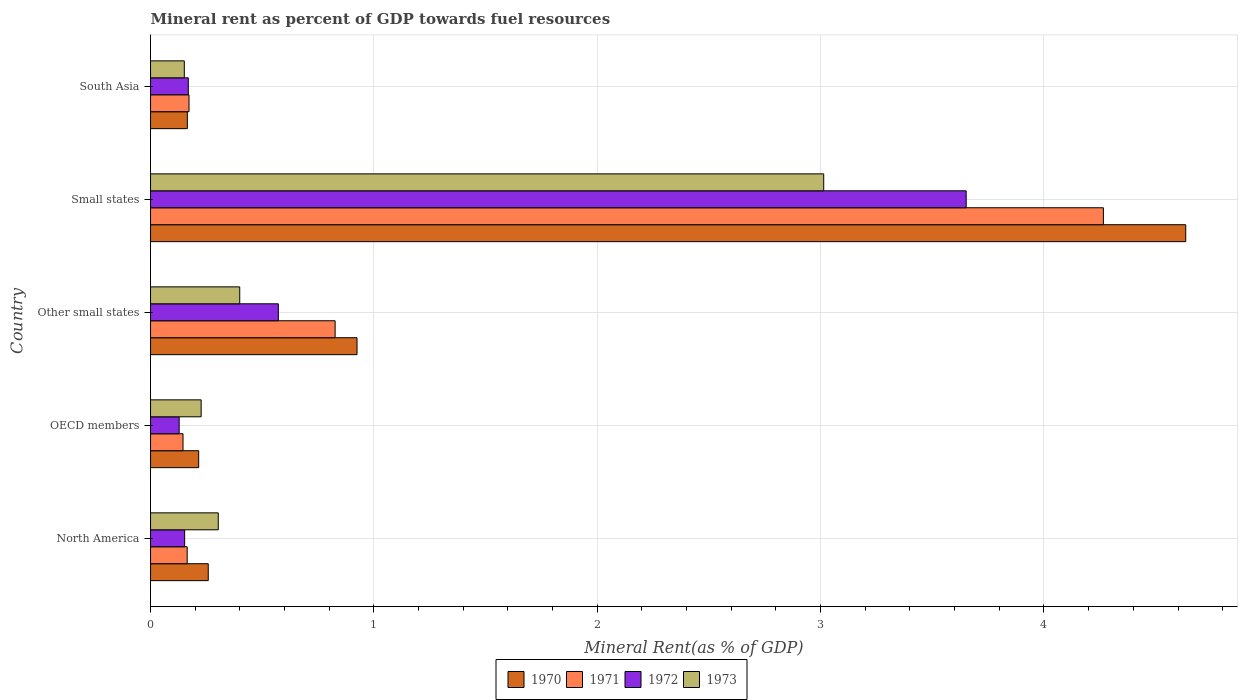How many different coloured bars are there?
Ensure brevity in your answer.  4. How many bars are there on the 1st tick from the top?
Make the answer very short. 4. How many bars are there on the 3rd tick from the bottom?
Offer a very short reply. 4. What is the mineral rent in 1971 in South Asia?
Your response must be concise. 0.17. Across all countries, what is the maximum mineral rent in 1973?
Your response must be concise. 3.01. Across all countries, what is the minimum mineral rent in 1971?
Make the answer very short. 0.15. In which country was the mineral rent in 1973 maximum?
Your answer should be compact. Small states. What is the total mineral rent in 1971 in the graph?
Give a very brief answer. 5.57. What is the difference between the mineral rent in 1971 in Small states and that in South Asia?
Your response must be concise. 4.09. What is the difference between the mineral rent in 1972 in OECD members and the mineral rent in 1970 in Small states?
Make the answer very short. -4.51. What is the average mineral rent in 1970 per country?
Make the answer very short. 1.24. What is the difference between the mineral rent in 1973 and mineral rent in 1970 in Other small states?
Offer a terse response. -0.53. In how many countries, is the mineral rent in 1973 greater than 4.6 %?
Your answer should be very brief. 0. What is the ratio of the mineral rent in 1972 in OECD members to that in Small states?
Your response must be concise. 0.04. Is the difference between the mineral rent in 1973 in Other small states and South Asia greater than the difference between the mineral rent in 1970 in Other small states and South Asia?
Keep it short and to the point. No. What is the difference between the highest and the second highest mineral rent in 1972?
Keep it short and to the point. 3.08. What is the difference between the highest and the lowest mineral rent in 1972?
Your answer should be compact. 3.52. In how many countries, is the mineral rent in 1973 greater than the average mineral rent in 1973 taken over all countries?
Offer a terse response. 1. What does the 1st bar from the top in Other small states represents?
Offer a very short reply. 1973. What does the 4th bar from the bottom in Small states represents?
Keep it short and to the point. 1973. Is it the case that in every country, the sum of the mineral rent in 1970 and mineral rent in 1973 is greater than the mineral rent in 1971?
Your answer should be very brief. Yes. How many bars are there?
Make the answer very short. 20. What is the difference between two consecutive major ticks on the X-axis?
Your response must be concise. 1. Are the values on the major ticks of X-axis written in scientific E-notation?
Make the answer very short. No. Does the graph contain any zero values?
Provide a short and direct response. No. What is the title of the graph?
Keep it short and to the point. Mineral rent as percent of GDP towards fuel resources. What is the label or title of the X-axis?
Your answer should be very brief. Mineral Rent(as % of GDP). What is the Mineral Rent(as % of GDP) of 1970 in North America?
Your response must be concise. 0.26. What is the Mineral Rent(as % of GDP) of 1971 in North America?
Provide a succinct answer. 0.16. What is the Mineral Rent(as % of GDP) in 1972 in North America?
Your answer should be compact. 0.15. What is the Mineral Rent(as % of GDP) of 1973 in North America?
Provide a short and direct response. 0.3. What is the Mineral Rent(as % of GDP) of 1970 in OECD members?
Provide a succinct answer. 0.22. What is the Mineral Rent(as % of GDP) of 1971 in OECD members?
Provide a succinct answer. 0.15. What is the Mineral Rent(as % of GDP) in 1972 in OECD members?
Your answer should be compact. 0.13. What is the Mineral Rent(as % of GDP) of 1973 in OECD members?
Offer a very short reply. 0.23. What is the Mineral Rent(as % of GDP) in 1970 in Other small states?
Your answer should be compact. 0.92. What is the Mineral Rent(as % of GDP) of 1971 in Other small states?
Keep it short and to the point. 0.83. What is the Mineral Rent(as % of GDP) in 1972 in Other small states?
Ensure brevity in your answer.  0.57. What is the Mineral Rent(as % of GDP) in 1973 in Other small states?
Your response must be concise. 0.4. What is the Mineral Rent(as % of GDP) of 1970 in Small states?
Keep it short and to the point. 4.63. What is the Mineral Rent(as % of GDP) of 1971 in Small states?
Your answer should be very brief. 4.27. What is the Mineral Rent(as % of GDP) of 1972 in Small states?
Provide a succinct answer. 3.65. What is the Mineral Rent(as % of GDP) in 1973 in Small states?
Your response must be concise. 3.01. What is the Mineral Rent(as % of GDP) of 1970 in South Asia?
Ensure brevity in your answer.  0.16. What is the Mineral Rent(as % of GDP) in 1971 in South Asia?
Provide a succinct answer. 0.17. What is the Mineral Rent(as % of GDP) in 1972 in South Asia?
Offer a very short reply. 0.17. What is the Mineral Rent(as % of GDP) of 1973 in South Asia?
Provide a succinct answer. 0.15. Across all countries, what is the maximum Mineral Rent(as % of GDP) of 1970?
Keep it short and to the point. 4.63. Across all countries, what is the maximum Mineral Rent(as % of GDP) in 1971?
Provide a succinct answer. 4.27. Across all countries, what is the maximum Mineral Rent(as % of GDP) of 1972?
Your answer should be compact. 3.65. Across all countries, what is the maximum Mineral Rent(as % of GDP) of 1973?
Your response must be concise. 3.01. Across all countries, what is the minimum Mineral Rent(as % of GDP) of 1970?
Offer a very short reply. 0.16. Across all countries, what is the minimum Mineral Rent(as % of GDP) in 1971?
Provide a short and direct response. 0.15. Across all countries, what is the minimum Mineral Rent(as % of GDP) in 1972?
Your response must be concise. 0.13. Across all countries, what is the minimum Mineral Rent(as % of GDP) in 1973?
Give a very brief answer. 0.15. What is the total Mineral Rent(as % of GDP) of 1970 in the graph?
Provide a short and direct response. 6.2. What is the total Mineral Rent(as % of GDP) in 1971 in the graph?
Your answer should be compact. 5.57. What is the total Mineral Rent(as % of GDP) in 1972 in the graph?
Provide a short and direct response. 4.67. What is the total Mineral Rent(as % of GDP) in 1973 in the graph?
Provide a short and direct response. 4.09. What is the difference between the Mineral Rent(as % of GDP) of 1970 in North America and that in OECD members?
Ensure brevity in your answer.  0.04. What is the difference between the Mineral Rent(as % of GDP) in 1971 in North America and that in OECD members?
Keep it short and to the point. 0.02. What is the difference between the Mineral Rent(as % of GDP) in 1972 in North America and that in OECD members?
Your answer should be compact. 0.02. What is the difference between the Mineral Rent(as % of GDP) of 1973 in North America and that in OECD members?
Provide a short and direct response. 0.08. What is the difference between the Mineral Rent(as % of GDP) in 1970 in North America and that in Other small states?
Offer a terse response. -0.67. What is the difference between the Mineral Rent(as % of GDP) of 1971 in North America and that in Other small states?
Offer a very short reply. -0.66. What is the difference between the Mineral Rent(as % of GDP) in 1972 in North America and that in Other small states?
Keep it short and to the point. -0.42. What is the difference between the Mineral Rent(as % of GDP) of 1973 in North America and that in Other small states?
Provide a succinct answer. -0.1. What is the difference between the Mineral Rent(as % of GDP) of 1970 in North America and that in Small states?
Offer a terse response. -4.38. What is the difference between the Mineral Rent(as % of GDP) in 1971 in North America and that in Small states?
Your response must be concise. -4.1. What is the difference between the Mineral Rent(as % of GDP) of 1972 in North America and that in Small states?
Your response must be concise. -3.5. What is the difference between the Mineral Rent(as % of GDP) of 1973 in North America and that in Small states?
Your answer should be very brief. -2.71. What is the difference between the Mineral Rent(as % of GDP) in 1970 in North America and that in South Asia?
Your response must be concise. 0.09. What is the difference between the Mineral Rent(as % of GDP) in 1971 in North America and that in South Asia?
Keep it short and to the point. -0.01. What is the difference between the Mineral Rent(as % of GDP) of 1972 in North America and that in South Asia?
Offer a very short reply. -0.02. What is the difference between the Mineral Rent(as % of GDP) of 1973 in North America and that in South Asia?
Keep it short and to the point. 0.15. What is the difference between the Mineral Rent(as % of GDP) of 1970 in OECD members and that in Other small states?
Your answer should be compact. -0.71. What is the difference between the Mineral Rent(as % of GDP) of 1971 in OECD members and that in Other small states?
Provide a short and direct response. -0.68. What is the difference between the Mineral Rent(as % of GDP) of 1972 in OECD members and that in Other small states?
Provide a succinct answer. -0.44. What is the difference between the Mineral Rent(as % of GDP) in 1973 in OECD members and that in Other small states?
Keep it short and to the point. -0.17. What is the difference between the Mineral Rent(as % of GDP) of 1970 in OECD members and that in Small states?
Offer a terse response. -4.42. What is the difference between the Mineral Rent(as % of GDP) in 1971 in OECD members and that in Small states?
Make the answer very short. -4.12. What is the difference between the Mineral Rent(as % of GDP) of 1972 in OECD members and that in Small states?
Give a very brief answer. -3.52. What is the difference between the Mineral Rent(as % of GDP) of 1973 in OECD members and that in Small states?
Ensure brevity in your answer.  -2.79. What is the difference between the Mineral Rent(as % of GDP) in 1970 in OECD members and that in South Asia?
Offer a terse response. 0.05. What is the difference between the Mineral Rent(as % of GDP) of 1971 in OECD members and that in South Asia?
Ensure brevity in your answer.  -0.03. What is the difference between the Mineral Rent(as % of GDP) of 1972 in OECD members and that in South Asia?
Your answer should be very brief. -0.04. What is the difference between the Mineral Rent(as % of GDP) of 1973 in OECD members and that in South Asia?
Offer a very short reply. 0.08. What is the difference between the Mineral Rent(as % of GDP) of 1970 in Other small states and that in Small states?
Your response must be concise. -3.71. What is the difference between the Mineral Rent(as % of GDP) of 1971 in Other small states and that in Small states?
Keep it short and to the point. -3.44. What is the difference between the Mineral Rent(as % of GDP) in 1972 in Other small states and that in Small states?
Offer a very short reply. -3.08. What is the difference between the Mineral Rent(as % of GDP) of 1973 in Other small states and that in Small states?
Your answer should be compact. -2.61. What is the difference between the Mineral Rent(as % of GDP) of 1970 in Other small states and that in South Asia?
Your answer should be very brief. 0.76. What is the difference between the Mineral Rent(as % of GDP) in 1971 in Other small states and that in South Asia?
Make the answer very short. 0.65. What is the difference between the Mineral Rent(as % of GDP) of 1972 in Other small states and that in South Asia?
Give a very brief answer. 0.4. What is the difference between the Mineral Rent(as % of GDP) of 1973 in Other small states and that in South Asia?
Ensure brevity in your answer.  0.25. What is the difference between the Mineral Rent(as % of GDP) in 1970 in Small states and that in South Asia?
Offer a very short reply. 4.47. What is the difference between the Mineral Rent(as % of GDP) of 1971 in Small states and that in South Asia?
Your answer should be compact. 4.09. What is the difference between the Mineral Rent(as % of GDP) in 1972 in Small states and that in South Asia?
Offer a terse response. 3.48. What is the difference between the Mineral Rent(as % of GDP) in 1973 in Small states and that in South Asia?
Ensure brevity in your answer.  2.86. What is the difference between the Mineral Rent(as % of GDP) in 1970 in North America and the Mineral Rent(as % of GDP) in 1971 in OECD members?
Provide a short and direct response. 0.11. What is the difference between the Mineral Rent(as % of GDP) in 1970 in North America and the Mineral Rent(as % of GDP) in 1972 in OECD members?
Offer a very short reply. 0.13. What is the difference between the Mineral Rent(as % of GDP) of 1970 in North America and the Mineral Rent(as % of GDP) of 1973 in OECD members?
Provide a short and direct response. 0.03. What is the difference between the Mineral Rent(as % of GDP) of 1971 in North America and the Mineral Rent(as % of GDP) of 1972 in OECD members?
Offer a terse response. 0.04. What is the difference between the Mineral Rent(as % of GDP) of 1971 in North America and the Mineral Rent(as % of GDP) of 1973 in OECD members?
Offer a very short reply. -0.06. What is the difference between the Mineral Rent(as % of GDP) in 1972 in North America and the Mineral Rent(as % of GDP) in 1973 in OECD members?
Give a very brief answer. -0.07. What is the difference between the Mineral Rent(as % of GDP) in 1970 in North America and the Mineral Rent(as % of GDP) in 1971 in Other small states?
Ensure brevity in your answer.  -0.57. What is the difference between the Mineral Rent(as % of GDP) of 1970 in North America and the Mineral Rent(as % of GDP) of 1972 in Other small states?
Your response must be concise. -0.31. What is the difference between the Mineral Rent(as % of GDP) in 1970 in North America and the Mineral Rent(as % of GDP) in 1973 in Other small states?
Offer a terse response. -0.14. What is the difference between the Mineral Rent(as % of GDP) of 1971 in North America and the Mineral Rent(as % of GDP) of 1972 in Other small states?
Offer a terse response. -0.41. What is the difference between the Mineral Rent(as % of GDP) in 1971 in North America and the Mineral Rent(as % of GDP) in 1973 in Other small states?
Ensure brevity in your answer.  -0.24. What is the difference between the Mineral Rent(as % of GDP) of 1972 in North America and the Mineral Rent(as % of GDP) of 1973 in Other small states?
Your response must be concise. -0.25. What is the difference between the Mineral Rent(as % of GDP) in 1970 in North America and the Mineral Rent(as % of GDP) in 1971 in Small states?
Offer a terse response. -4.01. What is the difference between the Mineral Rent(as % of GDP) of 1970 in North America and the Mineral Rent(as % of GDP) of 1972 in Small states?
Offer a very short reply. -3.39. What is the difference between the Mineral Rent(as % of GDP) of 1970 in North America and the Mineral Rent(as % of GDP) of 1973 in Small states?
Provide a succinct answer. -2.76. What is the difference between the Mineral Rent(as % of GDP) of 1971 in North America and the Mineral Rent(as % of GDP) of 1972 in Small states?
Offer a very short reply. -3.49. What is the difference between the Mineral Rent(as % of GDP) in 1971 in North America and the Mineral Rent(as % of GDP) in 1973 in Small states?
Ensure brevity in your answer.  -2.85. What is the difference between the Mineral Rent(as % of GDP) in 1972 in North America and the Mineral Rent(as % of GDP) in 1973 in Small states?
Your answer should be very brief. -2.86. What is the difference between the Mineral Rent(as % of GDP) of 1970 in North America and the Mineral Rent(as % of GDP) of 1971 in South Asia?
Ensure brevity in your answer.  0.09. What is the difference between the Mineral Rent(as % of GDP) in 1970 in North America and the Mineral Rent(as % of GDP) in 1972 in South Asia?
Offer a terse response. 0.09. What is the difference between the Mineral Rent(as % of GDP) in 1970 in North America and the Mineral Rent(as % of GDP) in 1973 in South Asia?
Keep it short and to the point. 0.11. What is the difference between the Mineral Rent(as % of GDP) in 1971 in North America and the Mineral Rent(as % of GDP) in 1972 in South Asia?
Ensure brevity in your answer.  -0.01. What is the difference between the Mineral Rent(as % of GDP) in 1971 in North America and the Mineral Rent(as % of GDP) in 1973 in South Asia?
Offer a terse response. 0.01. What is the difference between the Mineral Rent(as % of GDP) of 1972 in North America and the Mineral Rent(as % of GDP) of 1973 in South Asia?
Offer a terse response. 0. What is the difference between the Mineral Rent(as % of GDP) in 1970 in OECD members and the Mineral Rent(as % of GDP) in 1971 in Other small states?
Provide a short and direct response. -0.61. What is the difference between the Mineral Rent(as % of GDP) of 1970 in OECD members and the Mineral Rent(as % of GDP) of 1972 in Other small states?
Keep it short and to the point. -0.36. What is the difference between the Mineral Rent(as % of GDP) in 1970 in OECD members and the Mineral Rent(as % of GDP) in 1973 in Other small states?
Keep it short and to the point. -0.18. What is the difference between the Mineral Rent(as % of GDP) of 1971 in OECD members and the Mineral Rent(as % of GDP) of 1972 in Other small states?
Provide a short and direct response. -0.43. What is the difference between the Mineral Rent(as % of GDP) of 1971 in OECD members and the Mineral Rent(as % of GDP) of 1973 in Other small states?
Your answer should be very brief. -0.25. What is the difference between the Mineral Rent(as % of GDP) in 1972 in OECD members and the Mineral Rent(as % of GDP) in 1973 in Other small states?
Provide a succinct answer. -0.27. What is the difference between the Mineral Rent(as % of GDP) in 1970 in OECD members and the Mineral Rent(as % of GDP) in 1971 in Small states?
Provide a short and direct response. -4.05. What is the difference between the Mineral Rent(as % of GDP) in 1970 in OECD members and the Mineral Rent(as % of GDP) in 1972 in Small states?
Provide a short and direct response. -3.44. What is the difference between the Mineral Rent(as % of GDP) of 1970 in OECD members and the Mineral Rent(as % of GDP) of 1973 in Small states?
Your answer should be compact. -2.8. What is the difference between the Mineral Rent(as % of GDP) of 1971 in OECD members and the Mineral Rent(as % of GDP) of 1972 in Small states?
Make the answer very short. -3.51. What is the difference between the Mineral Rent(as % of GDP) of 1971 in OECD members and the Mineral Rent(as % of GDP) of 1973 in Small states?
Your answer should be very brief. -2.87. What is the difference between the Mineral Rent(as % of GDP) in 1972 in OECD members and the Mineral Rent(as % of GDP) in 1973 in Small states?
Give a very brief answer. -2.89. What is the difference between the Mineral Rent(as % of GDP) in 1970 in OECD members and the Mineral Rent(as % of GDP) in 1971 in South Asia?
Your answer should be compact. 0.04. What is the difference between the Mineral Rent(as % of GDP) in 1970 in OECD members and the Mineral Rent(as % of GDP) in 1972 in South Asia?
Make the answer very short. 0.05. What is the difference between the Mineral Rent(as % of GDP) in 1970 in OECD members and the Mineral Rent(as % of GDP) in 1973 in South Asia?
Offer a terse response. 0.06. What is the difference between the Mineral Rent(as % of GDP) in 1971 in OECD members and the Mineral Rent(as % of GDP) in 1972 in South Asia?
Give a very brief answer. -0.02. What is the difference between the Mineral Rent(as % of GDP) of 1971 in OECD members and the Mineral Rent(as % of GDP) of 1973 in South Asia?
Your answer should be compact. -0.01. What is the difference between the Mineral Rent(as % of GDP) in 1972 in OECD members and the Mineral Rent(as % of GDP) in 1973 in South Asia?
Provide a short and direct response. -0.02. What is the difference between the Mineral Rent(as % of GDP) of 1970 in Other small states and the Mineral Rent(as % of GDP) of 1971 in Small states?
Provide a succinct answer. -3.34. What is the difference between the Mineral Rent(as % of GDP) of 1970 in Other small states and the Mineral Rent(as % of GDP) of 1972 in Small states?
Offer a very short reply. -2.73. What is the difference between the Mineral Rent(as % of GDP) in 1970 in Other small states and the Mineral Rent(as % of GDP) in 1973 in Small states?
Provide a succinct answer. -2.09. What is the difference between the Mineral Rent(as % of GDP) of 1971 in Other small states and the Mineral Rent(as % of GDP) of 1972 in Small states?
Make the answer very short. -2.83. What is the difference between the Mineral Rent(as % of GDP) in 1971 in Other small states and the Mineral Rent(as % of GDP) in 1973 in Small states?
Keep it short and to the point. -2.19. What is the difference between the Mineral Rent(as % of GDP) in 1972 in Other small states and the Mineral Rent(as % of GDP) in 1973 in Small states?
Offer a terse response. -2.44. What is the difference between the Mineral Rent(as % of GDP) in 1970 in Other small states and the Mineral Rent(as % of GDP) in 1971 in South Asia?
Offer a very short reply. 0.75. What is the difference between the Mineral Rent(as % of GDP) in 1970 in Other small states and the Mineral Rent(as % of GDP) in 1972 in South Asia?
Your answer should be very brief. 0.76. What is the difference between the Mineral Rent(as % of GDP) of 1970 in Other small states and the Mineral Rent(as % of GDP) of 1973 in South Asia?
Provide a succinct answer. 0.77. What is the difference between the Mineral Rent(as % of GDP) in 1971 in Other small states and the Mineral Rent(as % of GDP) in 1972 in South Asia?
Keep it short and to the point. 0.66. What is the difference between the Mineral Rent(as % of GDP) in 1971 in Other small states and the Mineral Rent(as % of GDP) in 1973 in South Asia?
Provide a short and direct response. 0.68. What is the difference between the Mineral Rent(as % of GDP) of 1972 in Other small states and the Mineral Rent(as % of GDP) of 1973 in South Asia?
Ensure brevity in your answer.  0.42. What is the difference between the Mineral Rent(as % of GDP) of 1970 in Small states and the Mineral Rent(as % of GDP) of 1971 in South Asia?
Offer a very short reply. 4.46. What is the difference between the Mineral Rent(as % of GDP) of 1970 in Small states and the Mineral Rent(as % of GDP) of 1972 in South Asia?
Make the answer very short. 4.47. What is the difference between the Mineral Rent(as % of GDP) in 1970 in Small states and the Mineral Rent(as % of GDP) in 1973 in South Asia?
Give a very brief answer. 4.48. What is the difference between the Mineral Rent(as % of GDP) in 1971 in Small states and the Mineral Rent(as % of GDP) in 1972 in South Asia?
Ensure brevity in your answer.  4.1. What is the difference between the Mineral Rent(as % of GDP) of 1971 in Small states and the Mineral Rent(as % of GDP) of 1973 in South Asia?
Offer a terse response. 4.11. What is the difference between the Mineral Rent(as % of GDP) in 1972 in Small states and the Mineral Rent(as % of GDP) in 1973 in South Asia?
Make the answer very short. 3.5. What is the average Mineral Rent(as % of GDP) of 1970 per country?
Your answer should be very brief. 1.24. What is the average Mineral Rent(as % of GDP) in 1971 per country?
Keep it short and to the point. 1.11. What is the average Mineral Rent(as % of GDP) in 1972 per country?
Offer a terse response. 0.93. What is the average Mineral Rent(as % of GDP) in 1973 per country?
Make the answer very short. 0.82. What is the difference between the Mineral Rent(as % of GDP) of 1970 and Mineral Rent(as % of GDP) of 1971 in North America?
Your answer should be compact. 0.09. What is the difference between the Mineral Rent(as % of GDP) of 1970 and Mineral Rent(as % of GDP) of 1972 in North America?
Provide a short and direct response. 0.11. What is the difference between the Mineral Rent(as % of GDP) in 1970 and Mineral Rent(as % of GDP) in 1973 in North America?
Give a very brief answer. -0.04. What is the difference between the Mineral Rent(as % of GDP) of 1971 and Mineral Rent(as % of GDP) of 1972 in North America?
Your response must be concise. 0.01. What is the difference between the Mineral Rent(as % of GDP) of 1971 and Mineral Rent(as % of GDP) of 1973 in North America?
Your answer should be compact. -0.14. What is the difference between the Mineral Rent(as % of GDP) in 1972 and Mineral Rent(as % of GDP) in 1973 in North America?
Offer a very short reply. -0.15. What is the difference between the Mineral Rent(as % of GDP) in 1970 and Mineral Rent(as % of GDP) in 1971 in OECD members?
Offer a terse response. 0.07. What is the difference between the Mineral Rent(as % of GDP) of 1970 and Mineral Rent(as % of GDP) of 1972 in OECD members?
Provide a short and direct response. 0.09. What is the difference between the Mineral Rent(as % of GDP) of 1970 and Mineral Rent(as % of GDP) of 1973 in OECD members?
Your answer should be very brief. -0.01. What is the difference between the Mineral Rent(as % of GDP) of 1971 and Mineral Rent(as % of GDP) of 1972 in OECD members?
Provide a succinct answer. 0.02. What is the difference between the Mineral Rent(as % of GDP) of 1971 and Mineral Rent(as % of GDP) of 1973 in OECD members?
Offer a very short reply. -0.08. What is the difference between the Mineral Rent(as % of GDP) in 1972 and Mineral Rent(as % of GDP) in 1973 in OECD members?
Make the answer very short. -0.1. What is the difference between the Mineral Rent(as % of GDP) in 1970 and Mineral Rent(as % of GDP) in 1971 in Other small states?
Ensure brevity in your answer.  0.1. What is the difference between the Mineral Rent(as % of GDP) in 1970 and Mineral Rent(as % of GDP) in 1972 in Other small states?
Keep it short and to the point. 0.35. What is the difference between the Mineral Rent(as % of GDP) in 1970 and Mineral Rent(as % of GDP) in 1973 in Other small states?
Offer a terse response. 0.53. What is the difference between the Mineral Rent(as % of GDP) in 1971 and Mineral Rent(as % of GDP) in 1972 in Other small states?
Keep it short and to the point. 0.25. What is the difference between the Mineral Rent(as % of GDP) of 1971 and Mineral Rent(as % of GDP) of 1973 in Other small states?
Make the answer very short. 0.43. What is the difference between the Mineral Rent(as % of GDP) in 1972 and Mineral Rent(as % of GDP) in 1973 in Other small states?
Your response must be concise. 0.17. What is the difference between the Mineral Rent(as % of GDP) in 1970 and Mineral Rent(as % of GDP) in 1971 in Small states?
Keep it short and to the point. 0.37. What is the difference between the Mineral Rent(as % of GDP) of 1970 and Mineral Rent(as % of GDP) of 1972 in Small states?
Ensure brevity in your answer.  0.98. What is the difference between the Mineral Rent(as % of GDP) of 1970 and Mineral Rent(as % of GDP) of 1973 in Small states?
Offer a terse response. 1.62. What is the difference between the Mineral Rent(as % of GDP) in 1971 and Mineral Rent(as % of GDP) in 1972 in Small states?
Your answer should be very brief. 0.61. What is the difference between the Mineral Rent(as % of GDP) in 1971 and Mineral Rent(as % of GDP) in 1973 in Small states?
Your answer should be compact. 1.25. What is the difference between the Mineral Rent(as % of GDP) in 1972 and Mineral Rent(as % of GDP) in 1973 in Small states?
Keep it short and to the point. 0.64. What is the difference between the Mineral Rent(as % of GDP) in 1970 and Mineral Rent(as % of GDP) in 1971 in South Asia?
Your answer should be very brief. -0.01. What is the difference between the Mineral Rent(as % of GDP) of 1970 and Mineral Rent(as % of GDP) of 1972 in South Asia?
Provide a succinct answer. -0. What is the difference between the Mineral Rent(as % of GDP) of 1970 and Mineral Rent(as % of GDP) of 1973 in South Asia?
Make the answer very short. 0.01. What is the difference between the Mineral Rent(as % of GDP) of 1971 and Mineral Rent(as % of GDP) of 1972 in South Asia?
Your answer should be very brief. 0. What is the difference between the Mineral Rent(as % of GDP) in 1971 and Mineral Rent(as % of GDP) in 1973 in South Asia?
Make the answer very short. 0.02. What is the difference between the Mineral Rent(as % of GDP) in 1972 and Mineral Rent(as % of GDP) in 1973 in South Asia?
Make the answer very short. 0.02. What is the ratio of the Mineral Rent(as % of GDP) in 1970 in North America to that in OECD members?
Ensure brevity in your answer.  1.2. What is the ratio of the Mineral Rent(as % of GDP) of 1971 in North America to that in OECD members?
Offer a terse response. 1.13. What is the ratio of the Mineral Rent(as % of GDP) in 1972 in North America to that in OECD members?
Your answer should be very brief. 1.19. What is the ratio of the Mineral Rent(as % of GDP) in 1973 in North America to that in OECD members?
Your answer should be compact. 1.34. What is the ratio of the Mineral Rent(as % of GDP) of 1970 in North America to that in Other small states?
Offer a terse response. 0.28. What is the ratio of the Mineral Rent(as % of GDP) of 1971 in North America to that in Other small states?
Offer a terse response. 0.2. What is the ratio of the Mineral Rent(as % of GDP) of 1972 in North America to that in Other small states?
Your answer should be very brief. 0.27. What is the ratio of the Mineral Rent(as % of GDP) in 1973 in North America to that in Other small states?
Offer a terse response. 0.76. What is the ratio of the Mineral Rent(as % of GDP) in 1970 in North America to that in Small states?
Keep it short and to the point. 0.06. What is the ratio of the Mineral Rent(as % of GDP) of 1971 in North America to that in Small states?
Make the answer very short. 0.04. What is the ratio of the Mineral Rent(as % of GDP) of 1972 in North America to that in Small states?
Offer a very short reply. 0.04. What is the ratio of the Mineral Rent(as % of GDP) of 1973 in North America to that in Small states?
Your response must be concise. 0.1. What is the ratio of the Mineral Rent(as % of GDP) of 1970 in North America to that in South Asia?
Your answer should be compact. 1.57. What is the ratio of the Mineral Rent(as % of GDP) in 1971 in North America to that in South Asia?
Offer a terse response. 0.95. What is the ratio of the Mineral Rent(as % of GDP) in 1972 in North America to that in South Asia?
Offer a terse response. 0.9. What is the ratio of the Mineral Rent(as % of GDP) of 1973 in North America to that in South Asia?
Your answer should be very brief. 2.01. What is the ratio of the Mineral Rent(as % of GDP) in 1970 in OECD members to that in Other small states?
Keep it short and to the point. 0.23. What is the ratio of the Mineral Rent(as % of GDP) in 1971 in OECD members to that in Other small states?
Provide a succinct answer. 0.18. What is the ratio of the Mineral Rent(as % of GDP) in 1972 in OECD members to that in Other small states?
Make the answer very short. 0.22. What is the ratio of the Mineral Rent(as % of GDP) in 1973 in OECD members to that in Other small states?
Make the answer very short. 0.57. What is the ratio of the Mineral Rent(as % of GDP) in 1970 in OECD members to that in Small states?
Ensure brevity in your answer.  0.05. What is the ratio of the Mineral Rent(as % of GDP) in 1971 in OECD members to that in Small states?
Provide a short and direct response. 0.03. What is the ratio of the Mineral Rent(as % of GDP) of 1972 in OECD members to that in Small states?
Keep it short and to the point. 0.04. What is the ratio of the Mineral Rent(as % of GDP) in 1973 in OECD members to that in Small states?
Your answer should be compact. 0.08. What is the ratio of the Mineral Rent(as % of GDP) in 1970 in OECD members to that in South Asia?
Keep it short and to the point. 1.31. What is the ratio of the Mineral Rent(as % of GDP) in 1971 in OECD members to that in South Asia?
Provide a short and direct response. 0.84. What is the ratio of the Mineral Rent(as % of GDP) of 1972 in OECD members to that in South Asia?
Provide a short and direct response. 0.76. What is the ratio of the Mineral Rent(as % of GDP) of 1973 in OECD members to that in South Asia?
Your answer should be compact. 1.5. What is the ratio of the Mineral Rent(as % of GDP) of 1970 in Other small states to that in Small states?
Keep it short and to the point. 0.2. What is the ratio of the Mineral Rent(as % of GDP) of 1971 in Other small states to that in Small states?
Your response must be concise. 0.19. What is the ratio of the Mineral Rent(as % of GDP) of 1972 in Other small states to that in Small states?
Ensure brevity in your answer.  0.16. What is the ratio of the Mineral Rent(as % of GDP) of 1973 in Other small states to that in Small states?
Give a very brief answer. 0.13. What is the ratio of the Mineral Rent(as % of GDP) of 1970 in Other small states to that in South Asia?
Make the answer very short. 5.61. What is the ratio of the Mineral Rent(as % of GDP) in 1971 in Other small states to that in South Asia?
Make the answer very short. 4.8. What is the ratio of the Mineral Rent(as % of GDP) in 1972 in Other small states to that in South Asia?
Ensure brevity in your answer.  3.38. What is the ratio of the Mineral Rent(as % of GDP) in 1973 in Other small states to that in South Asia?
Your answer should be compact. 2.64. What is the ratio of the Mineral Rent(as % of GDP) of 1970 in Small states to that in South Asia?
Give a very brief answer. 28.13. What is the ratio of the Mineral Rent(as % of GDP) in 1971 in Small states to that in South Asia?
Keep it short and to the point. 24.77. What is the ratio of the Mineral Rent(as % of GDP) in 1972 in Small states to that in South Asia?
Ensure brevity in your answer.  21.6. What is the ratio of the Mineral Rent(as % of GDP) of 1973 in Small states to that in South Asia?
Make the answer very short. 19.93. What is the difference between the highest and the second highest Mineral Rent(as % of GDP) in 1970?
Make the answer very short. 3.71. What is the difference between the highest and the second highest Mineral Rent(as % of GDP) in 1971?
Keep it short and to the point. 3.44. What is the difference between the highest and the second highest Mineral Rent(as % of GDP) in 1972?
Give a very brief answer. 3.08. What is the difference between the highest and the second highest Mineral Rent(as % of GDP) of 1973?
Keep it short and to the point. 2.61. What is the difference between the highest and the lowest Mineral Rent(as % of GDP) in 1970?
Ensure brevity in your answer.  4.47. What is the difference between the highest and the lowest Mineral Rent(as % of GDP) of 1971?
Your answer should be compact. 4.12. What is the difference between the highest and the lowest Mineral Rent(as % of GDP) of 1972?
Ensure brevity in your answer.  3.52. What is the difference between the highest and the lowest Mineral Rent(as % of GDP) of 1973?
Your response must be concise. 2.86. 